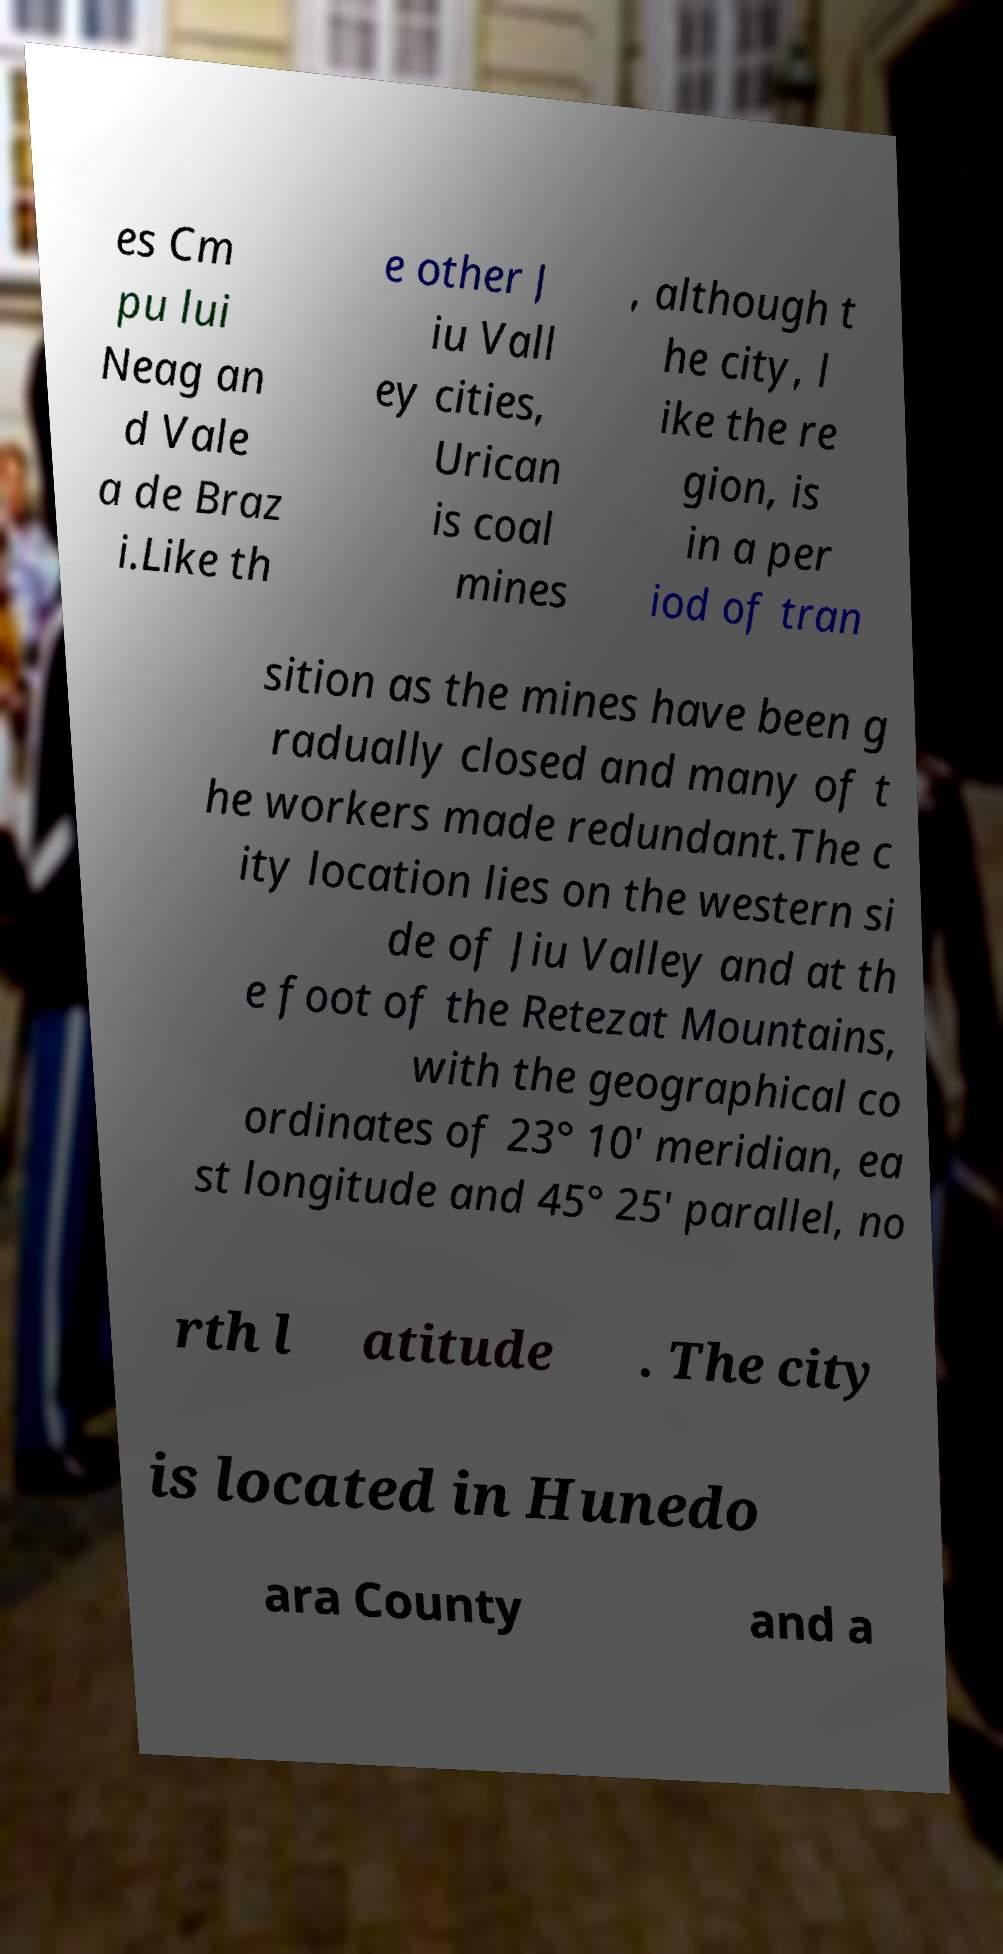Please identify and transcribe the text found in this image. es Cm pu lui Neag an d Vale a de Braz i.Like th e other J iu Vall ey cities, Urican is coal mines , although t he city, l ike the re gion, is in a per iod of tran sition as the mines have been g radually closed and many of t he workers made redundant.The c ity location lies on the western si de of Jiu Valley and at th e foot of the Retezat Mountains, with the geographical co ordinates of 23° 10′ meridian, ea st longitude and 45° 25′ parallel, no rth l atitude . The city is located in Hunedo ara County and a 